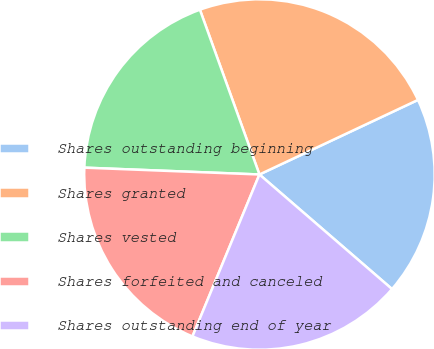Convert chart. <chart><loc_0><loc_0><loc_500><loc_500><pie_chart><fcel>Shares outstanding beginning<fcel>Shares granted<fcel>Shares vested<fcel>Shares forfeited and canceled<fcel>Shares outstanding end of year<nl><fcel>18.34%<fcel>23.52%<fcel>18.86%<fcel>19.38%<fcel>19.9%<nl></chart> 